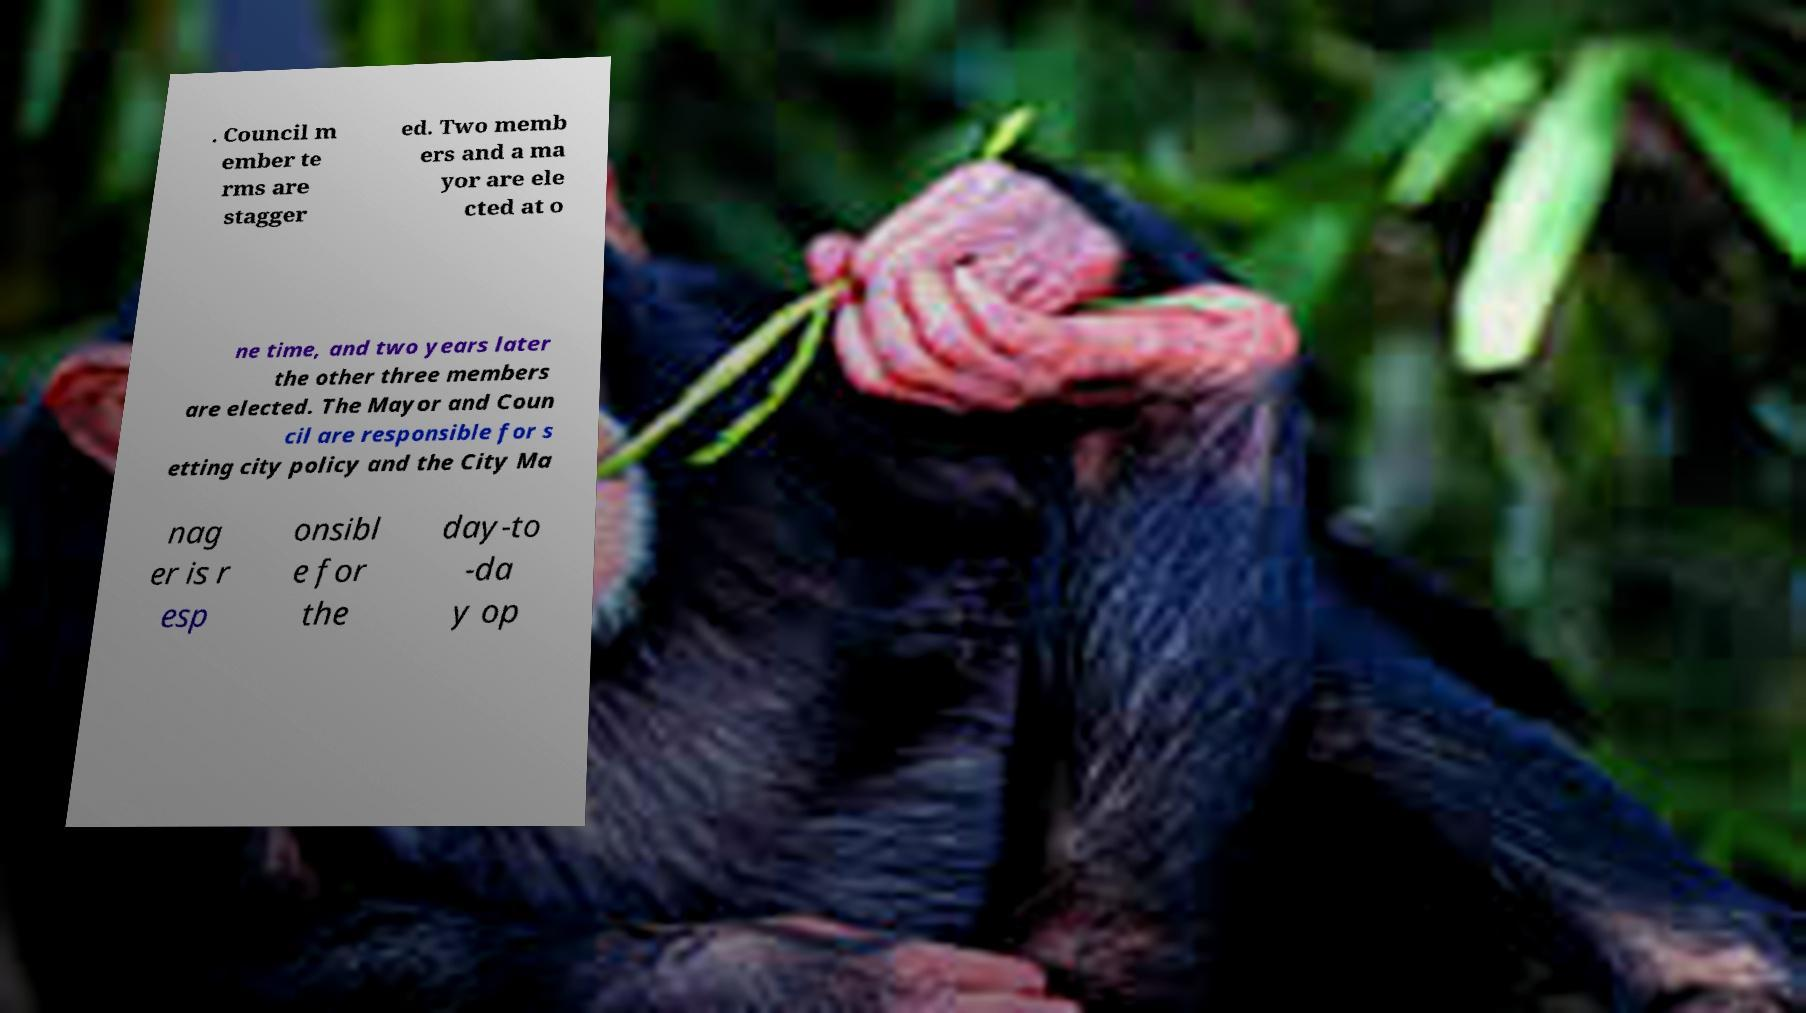There's text embedded in this image that I need extracted. Can you transcribe it verbatim? . Council m ember te rms are stagger ed. Two memb ers and a ma yor are ele cted at o ne time, and two years later the other three members are elected. The Mayor and Coun cil are responsible for s etting city policy and the City Ma nag er is r esp onsibl e for the day-to -da y op 